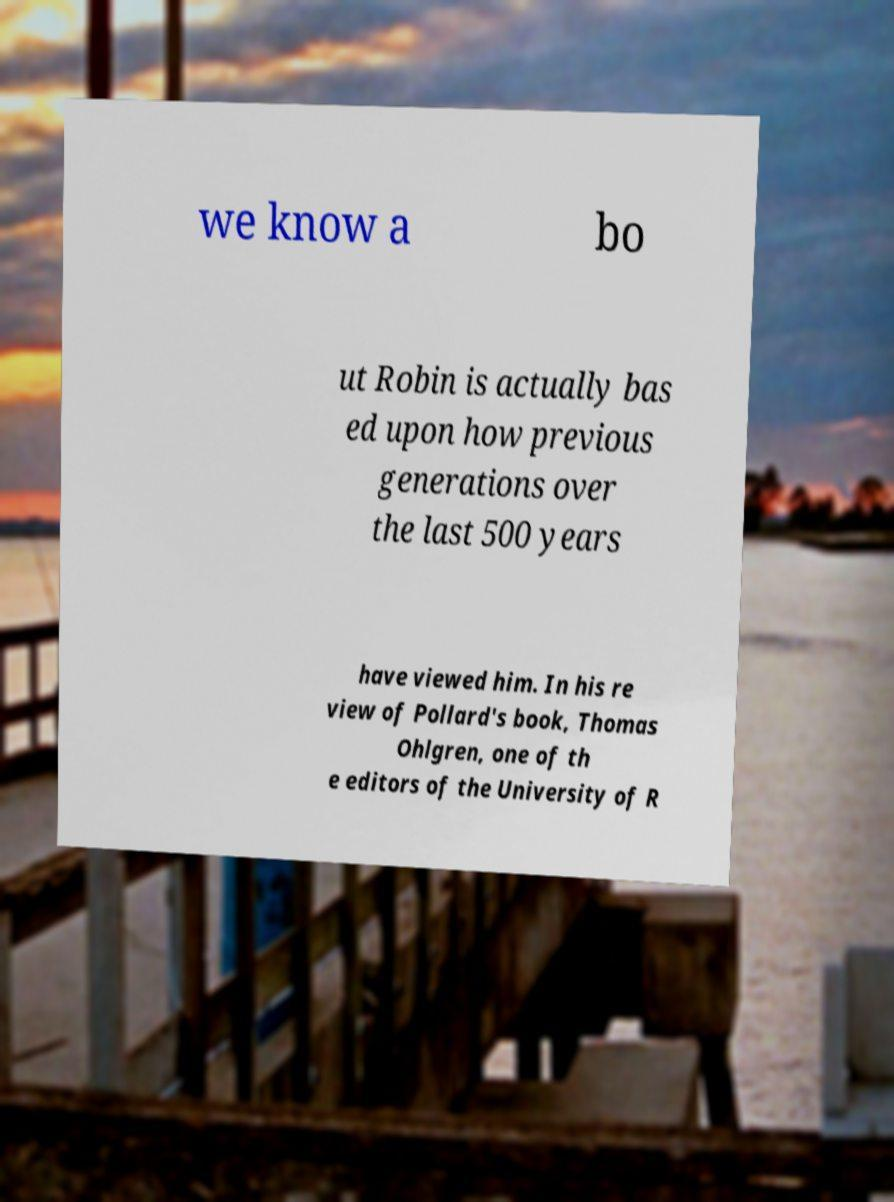Please identify and transcribe the text found in this image. we know a bo ut Robin is actually bas ed upon how previous generations over the last 500 years have viewed him. In his re view of Pollard's book, Thomas Ohlgren, one of th e editors of the University of R 